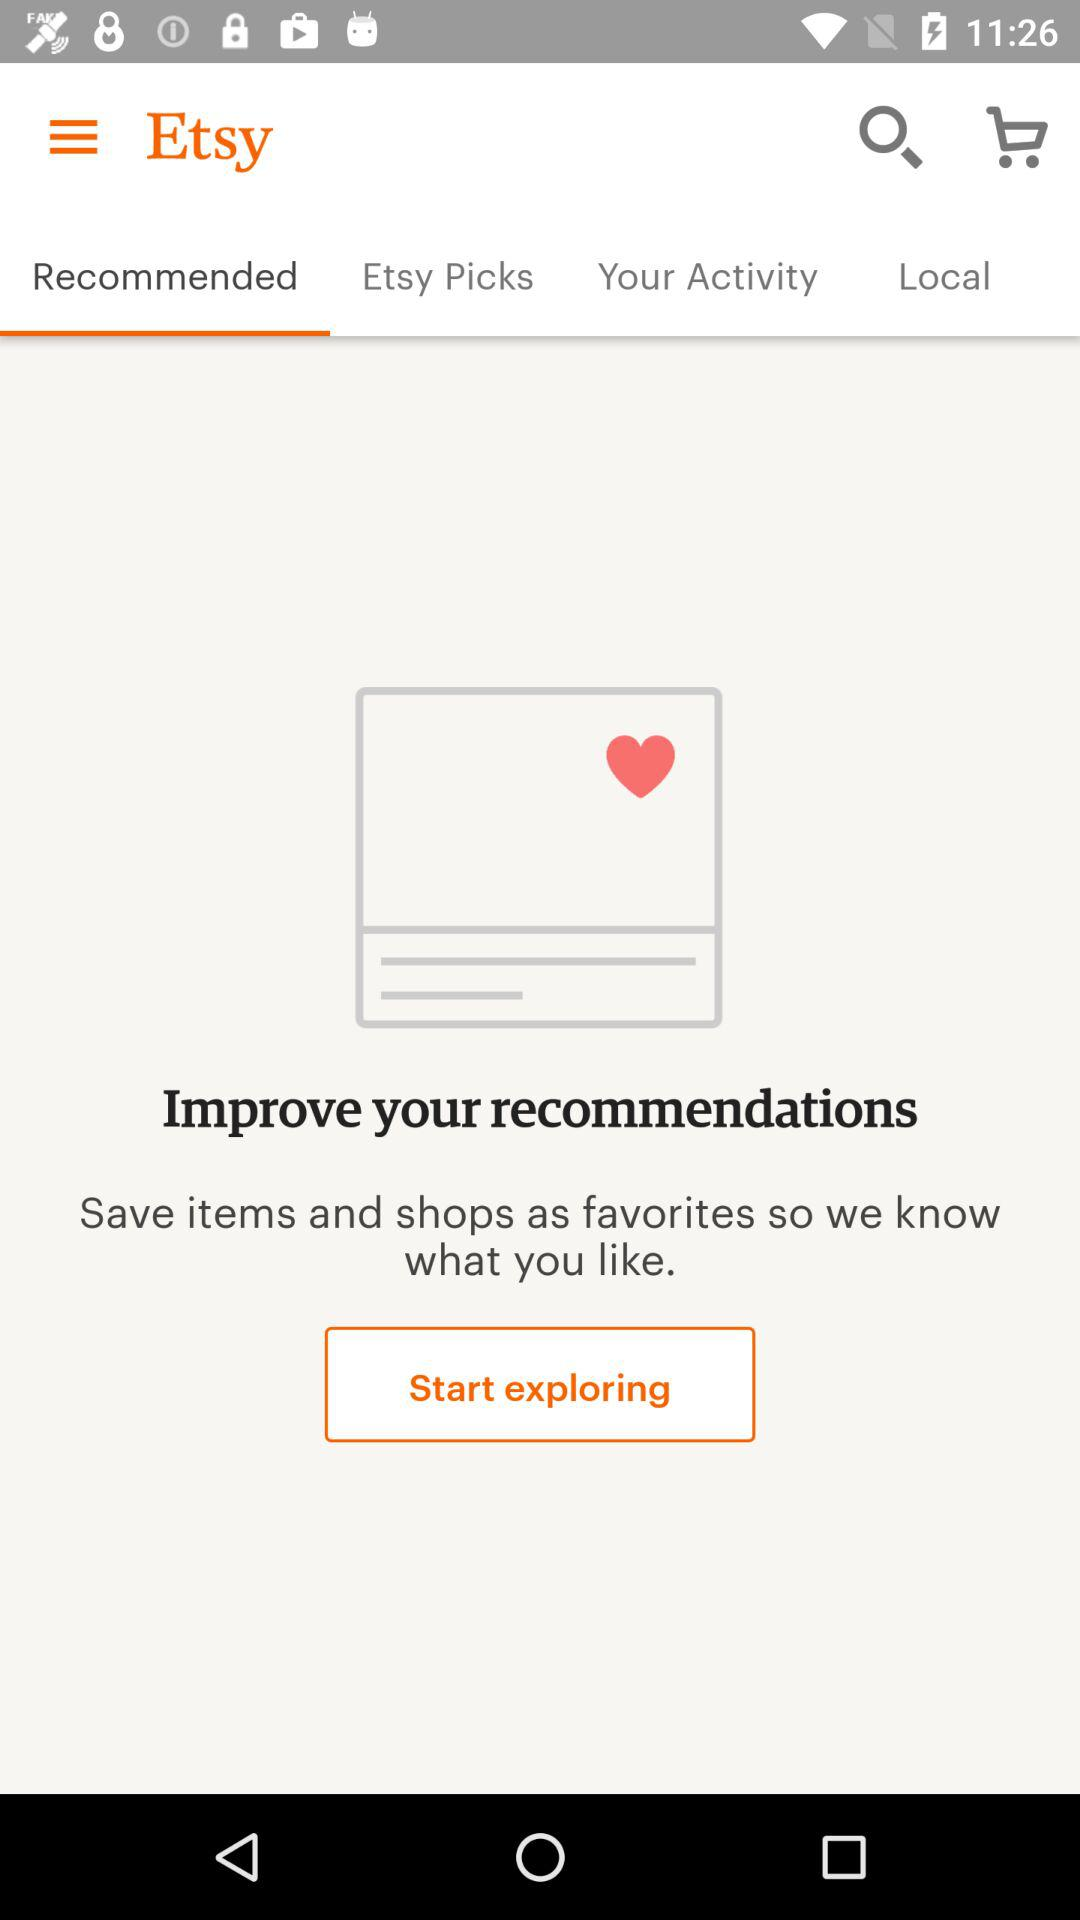Which tab has been selected? The selected tab is "Recommended". 